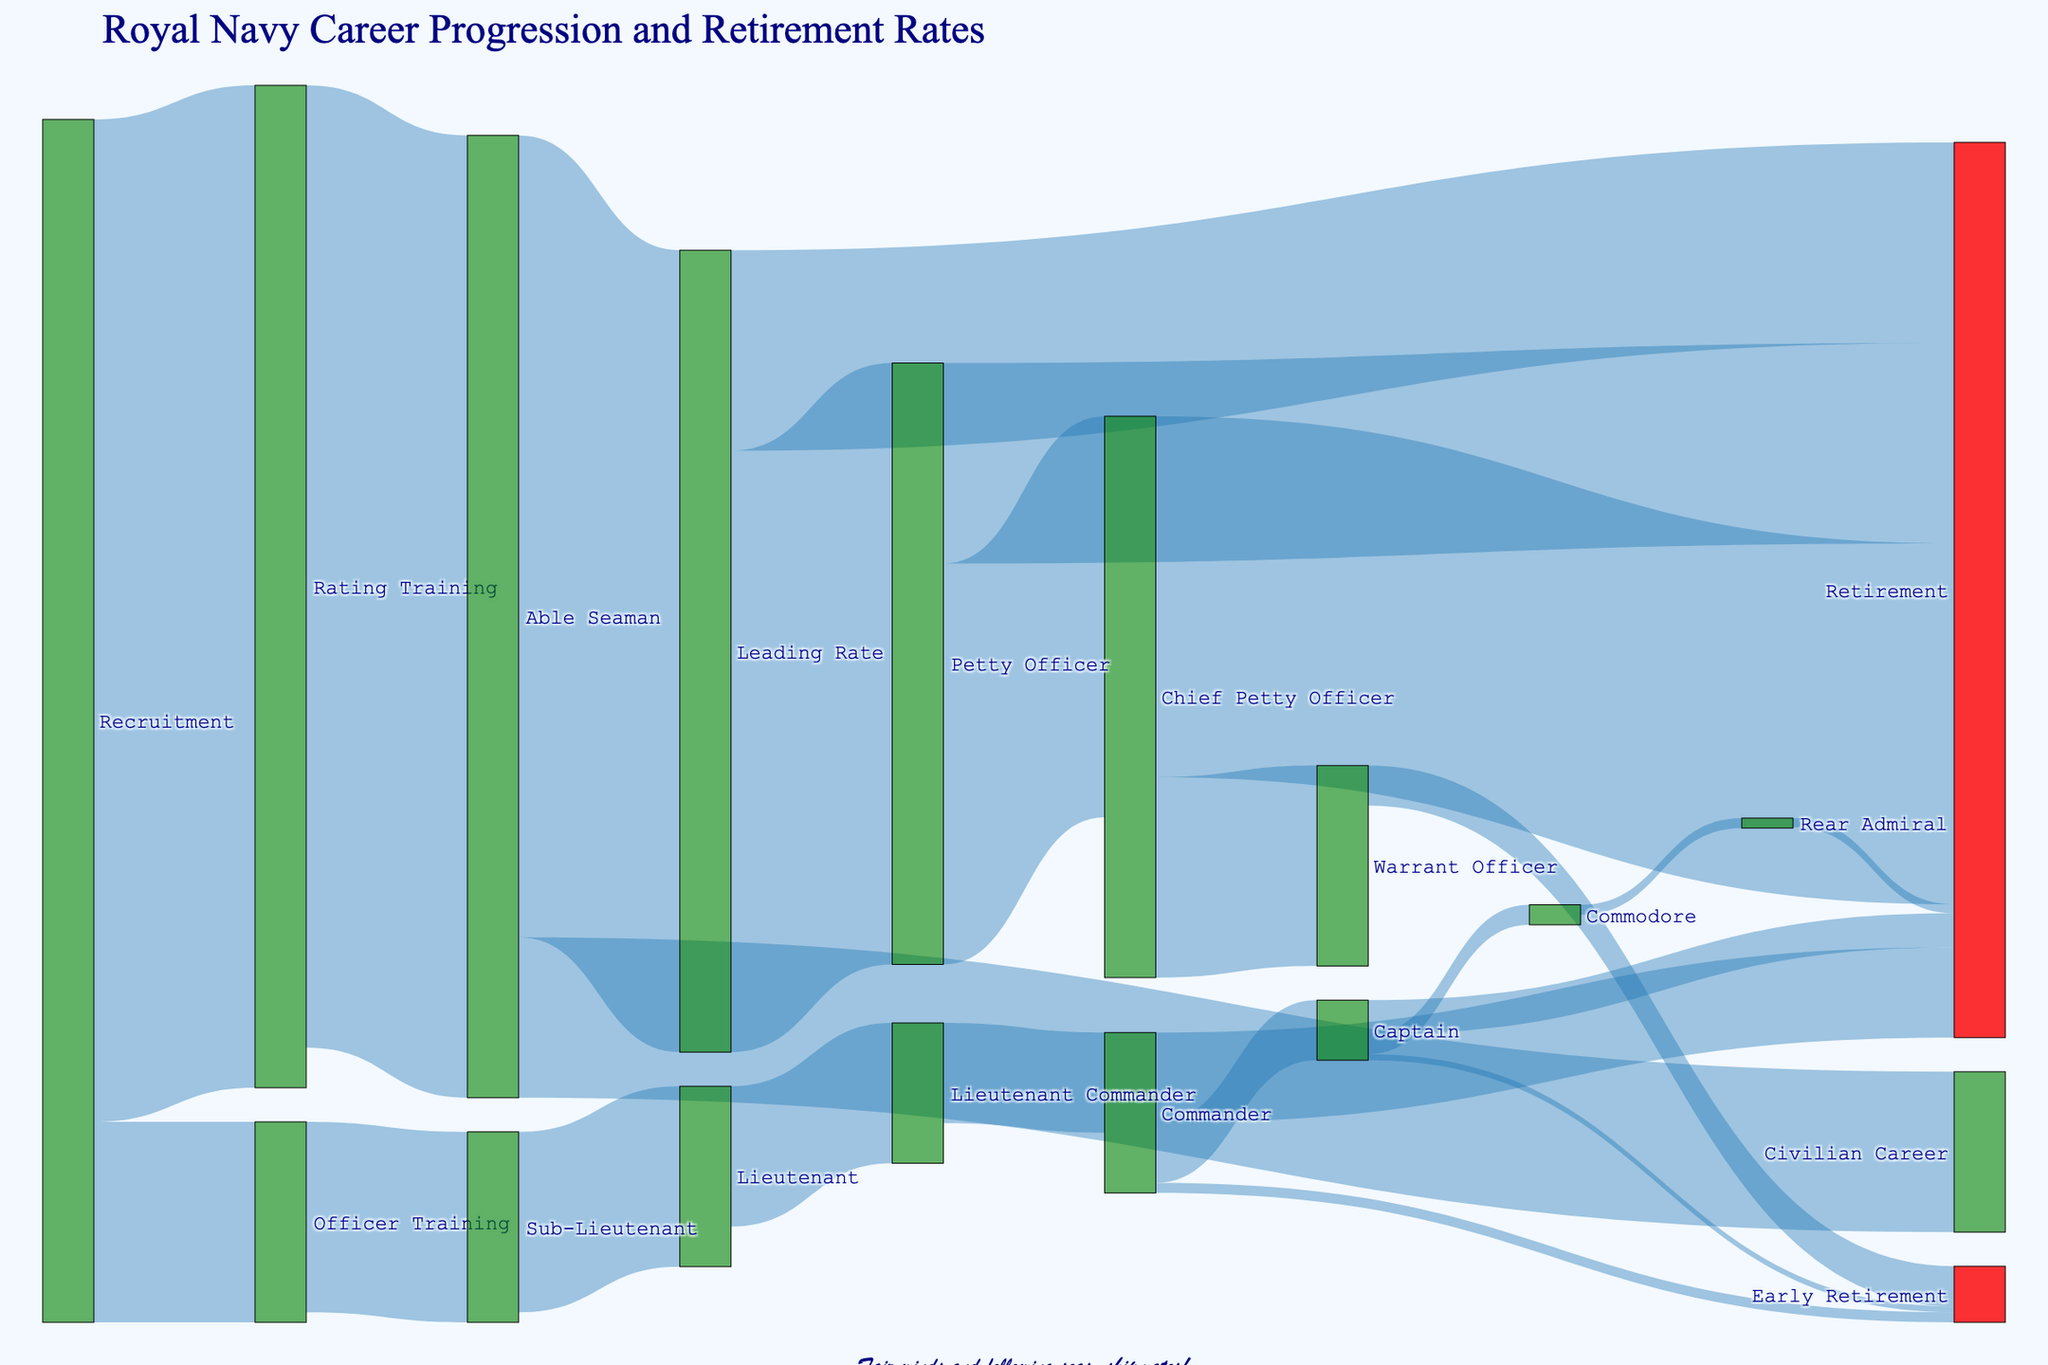How many people started their Royal Navy career with Officer Training? The figure shows the flow from "Recruitment" to "Officer Training". According to the data, 1000 people are recruited into Officer Training.
Answer: 1000 How many individuals transitioned from Sub-Lieutenant to Lieutenant? The diagram indicates the number of people moving from "Sub-Lieutenant" to "Lieutenant", which is 900.
Answer: 900 Which is the larger group: those who became Petty Officers from Leading Rate, or those who took early retirement from Warrant Officer? The figure indicates 3000 Petty Officers moving from Leading Rate, while 200 Warrant Officers took early retirement. 3000 is larger than 200.
Answer: Leading Rate to Petty Officer What is the color representation of retirement nodes? Retirement nodes in the figure are depicted as red-colored nodes.
Answer: Red Of those who were recruited and later ended up in Civilian Careers, how many were there? The flow in the diagram from "Able Seaman" to "Civilian Career" shows that 800 individuals made this transition.
Answer: 800 What is the total number of people who achieved the rank of Commander? Summing the flow values to "Commander", (500 from Lieutenant Commander and 50 early retirement) yields 500 + 50 = 550.
Answer: 550 Comparing the transition from Commander to Captain, and Petty Officer to Chief Petty Officer, which had a larger number? The transition value from "Commander" to "Captain" is 300 and from "Petty Officer" to "Chief Petty Officer" is 2000. 2000 is larger than 300.
Answer: Petty Officer to Chief Petty Officer Which rank has more individuals retiring from it, Commander or Captain? The diagram shows 450 individuals retiring as "Commander" versus 170 as "Captain". 450 is greater than 170.
Answer: Commander What is the primary route for individuals who retire early? The figure indicates pathways for early retirement, with the largest flow being from "Warrant Officer" at 200 individuals.
Answer: Warrant Officer How many Commodores eventually become Rear Admirals? The diagram shows that 50 people transition from "Commodore" to "Rear Admiral".
Answer: 50 